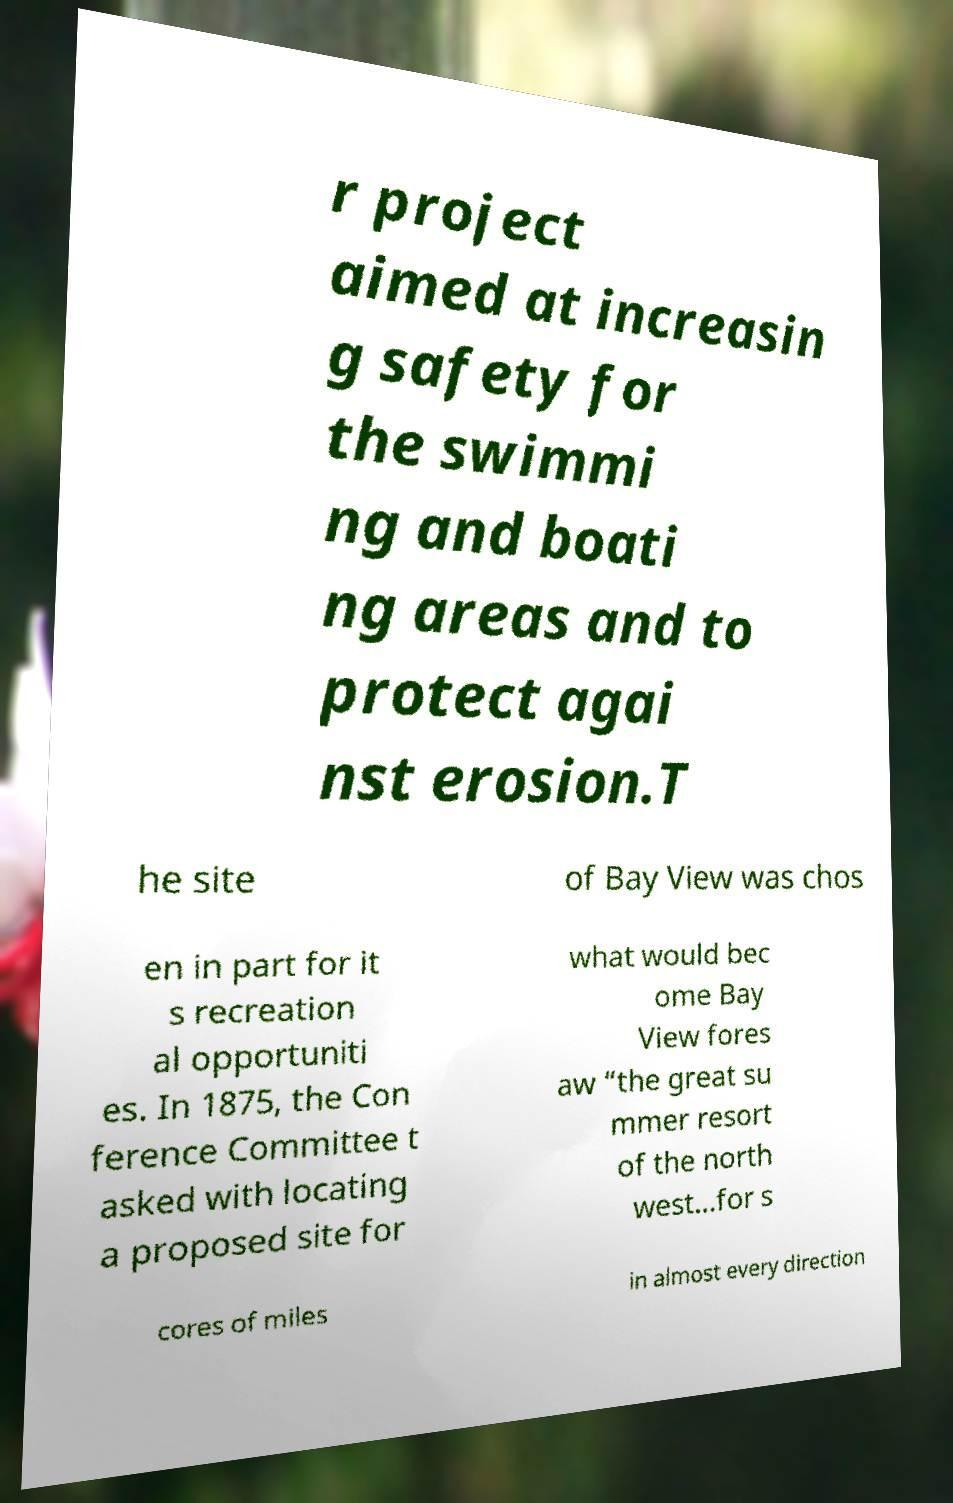For documentation purposes, I need the text within this image transcribed. Could you provide that? r project aimed at increasin g safety for the swimmi ng and boati ng areas and to protect agai nst erosion.T he site of Bay View was chos en in part for it s recreation al opportuniti es. In 1875, the Con ference Committee t asked with locating a proposed site for what would bec ome Bay View fores aw “the great su mmer resort of the north west…for s cores of miles in almost every direction 